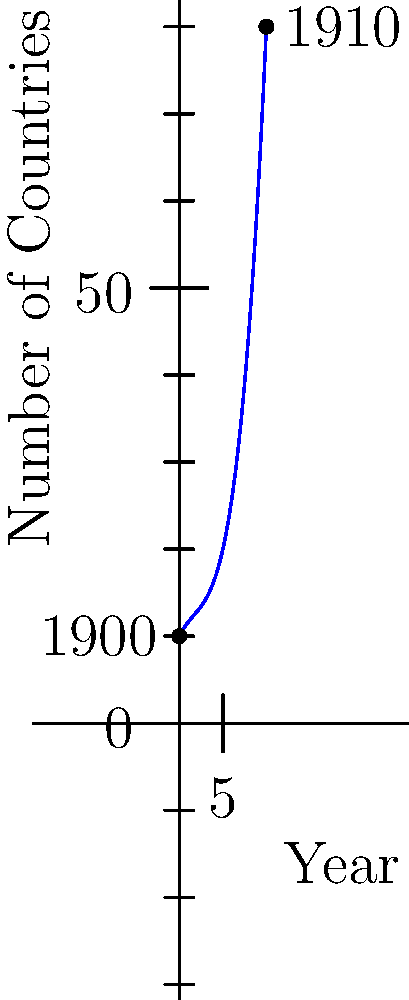The cubic polynomial graph above represents the growth of countries granting women's suffrage from 1900 to 1910. If the function is given by $f(x) = 0.1x^3 - 0.5x^2 + 2x + 10$, where $x$ represents the number of years since 1900, what was the approximate rate of change in the number of countries granting women's suffrage between 1905 and 1910? To find the rate of change between 1905 and 1910:

1. Calculate $f(5)$ and $f(10)$:
   $f(5) = 0.1(5^3) - 0.5(5^2) + 2(5) + 10 = 12.5 - 12.5 + 10 + 10 = 20$
   $f(10) = 0.1(10^3) - 0.5(10^2) + 2(10) + 10 = 100 - 50 + 20 + 10 = 80$

2. Calculate the change in y (number of countries):
   $\Delta y = f(10) - f(5) = 80 - 20 = 60$

3. Calculate the change in x (years):
   $\Delta x = 10 - 5 = 5$

4. Calculate the rate of change:
   Rate of change = $\frac{\Delta y}{\Delta x} = \frac{60}{5} = 12$

Therefore, the approximate rate of change in the number of countries granting women's suffrage between 1905 and 1910 was 12 countries per year.
Answer: 12 countries per year 